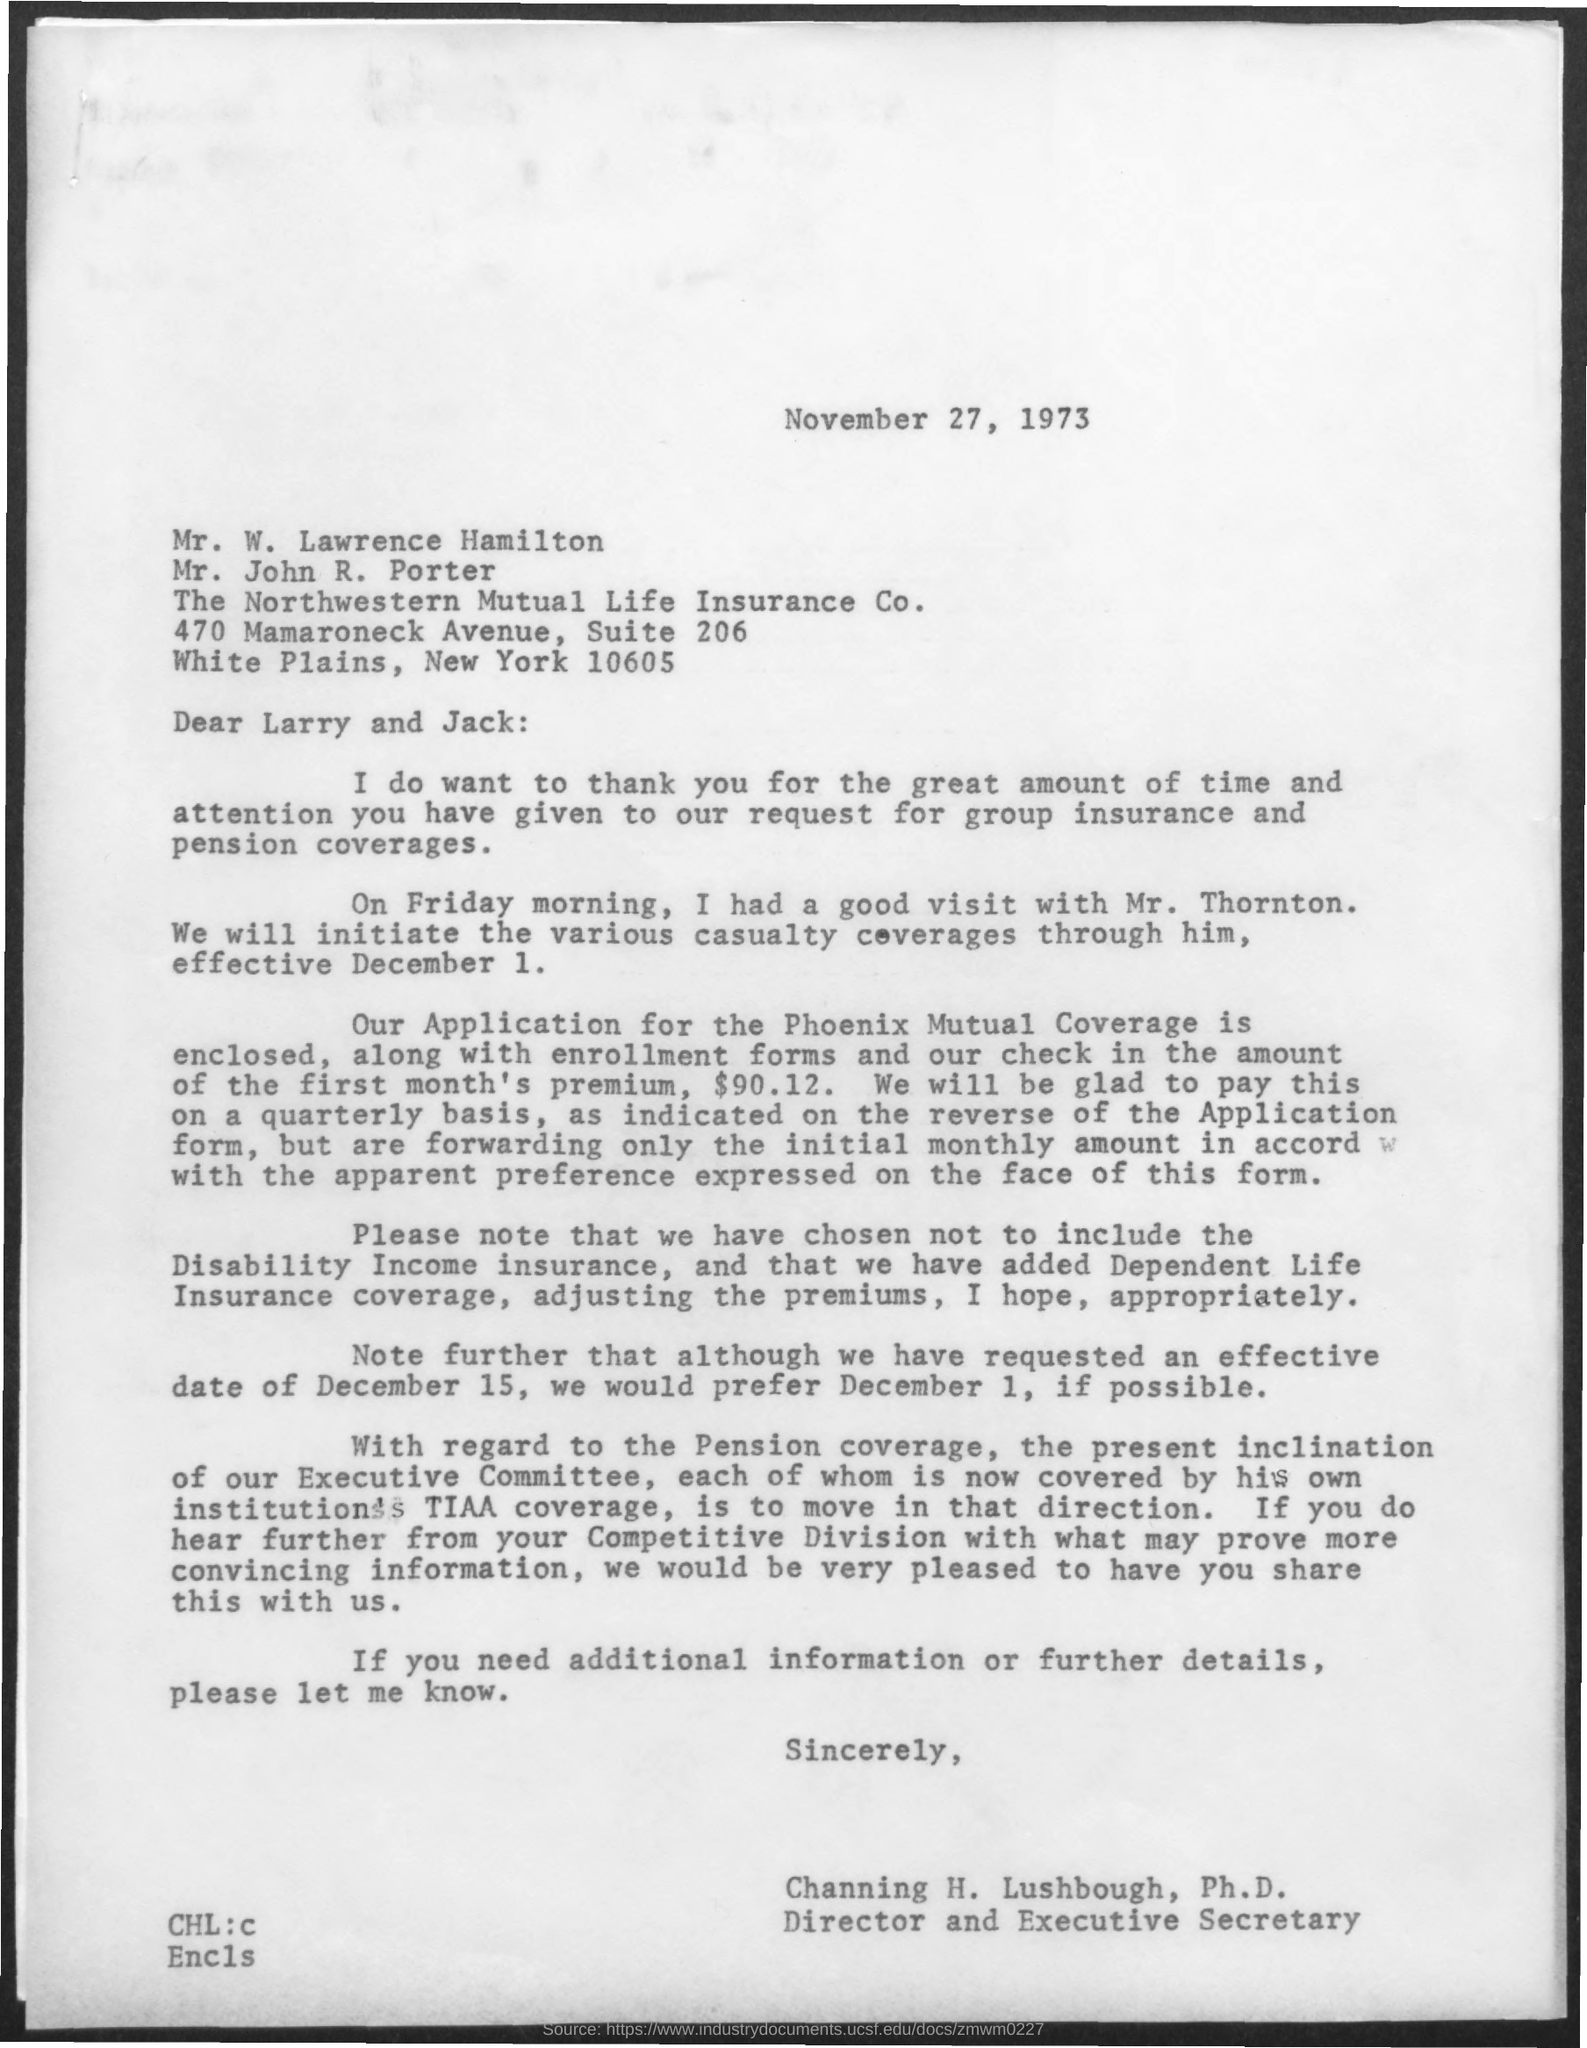What is the date on the document?
Your answer should be compact. NOVEMBER 27, 1973. What is the check amount enclosed?
Offer a terse response. $90.12. Who is this letter from?
Your response must be concise. Channing h. lushbough, ph.d. 